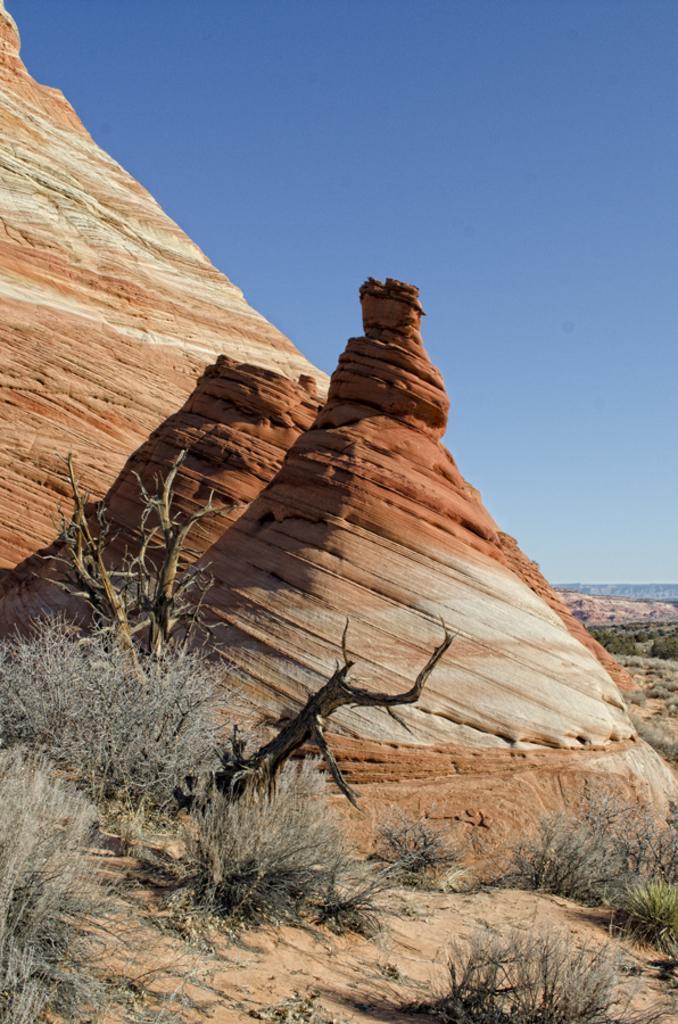Could you give a brief overview of what you see in this image? In the image we can some hills, on the hills there are some trees. At the top of the image there is sky. 